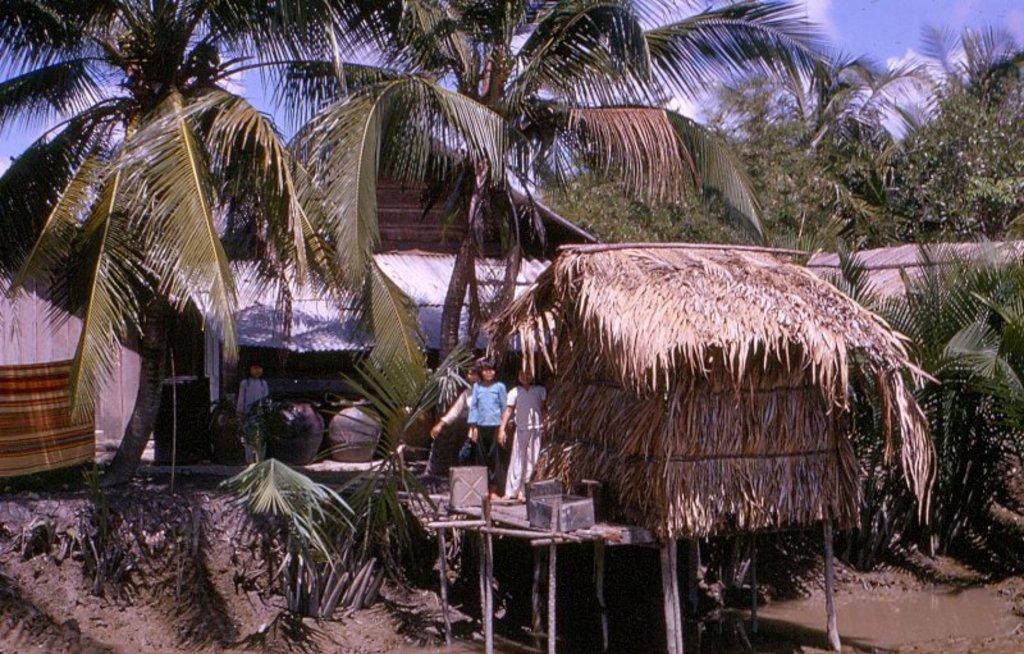Could you give a brief overview of what you see in this image? This is an outside view. Here I can see few huts and many trees. In the middle of the image I can see few people are standing on a wooden plank. In the bottom right, I can see some water on the ground. At the top of the image I can see the sky. 